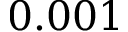<formula> <loc_0><loc_0><loc_500><loc_500>0 . 0 0 1</formula> 